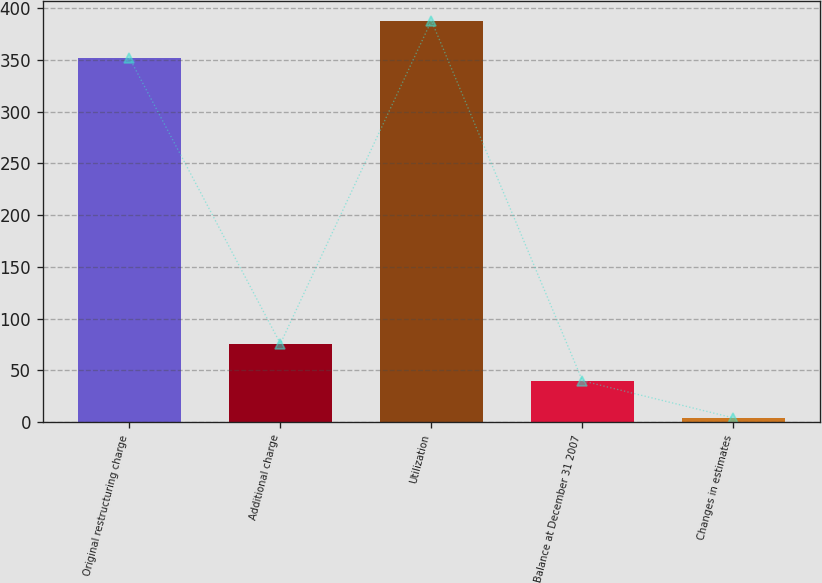<chart> <loc_0><loc_0><loc_500><loc_500><bar_chart><fcel>Original restructuring charge<fcel>Additional charge<fcel>Utilization<fcel>Balance at December 31 2007<fcel>Changes in estimates<nl><fcel>352<fcel>75.8<fcel>387.9<fcel>39.9<fcel>4<nl></chart> 